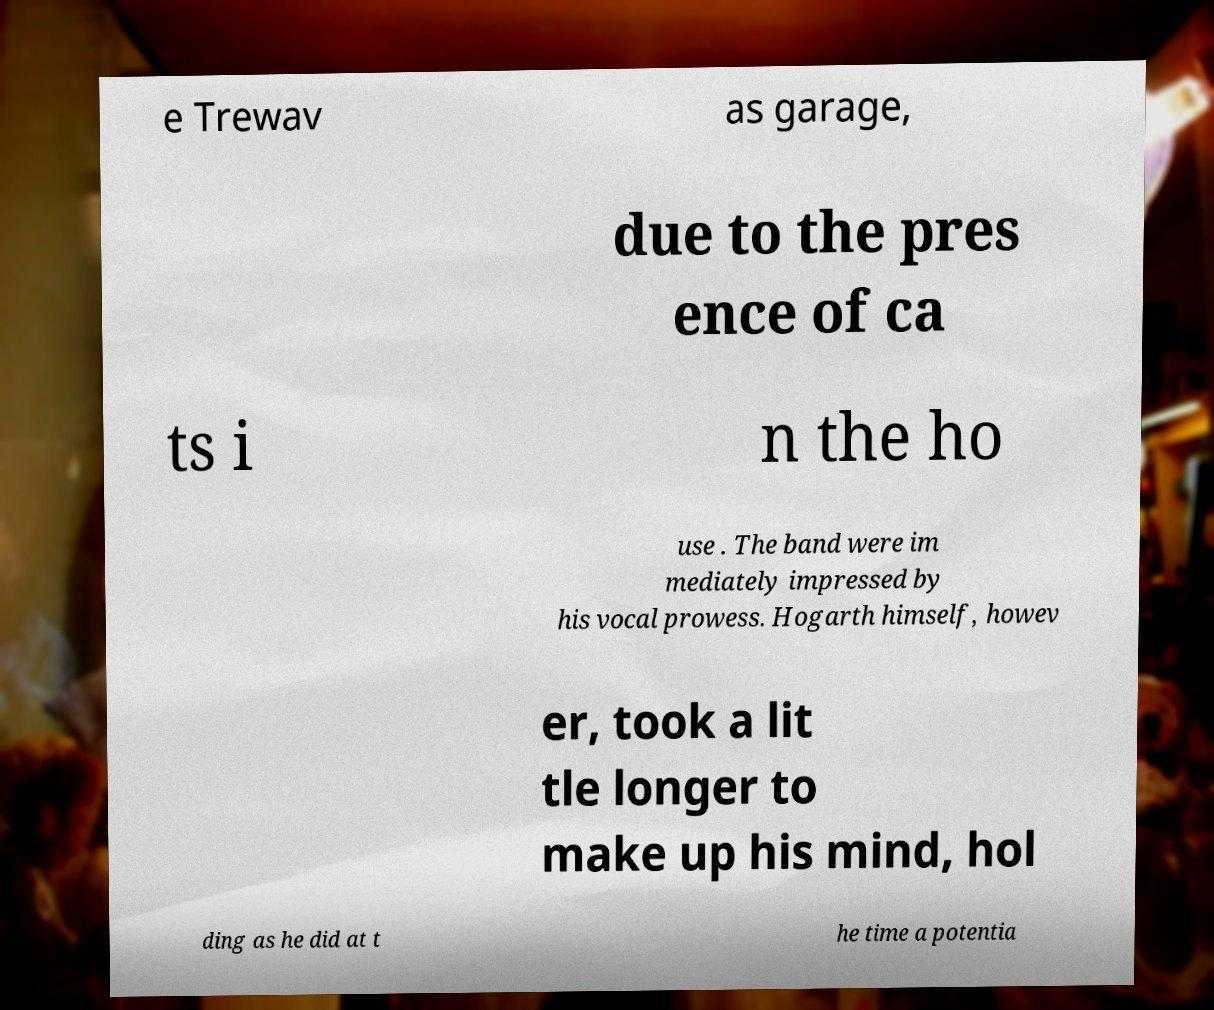Please read and relay the text visible in this image. What does it say? e Trewav as garage, due to the pres ence of ca ts i n the ho use . The band were im mediately impressed by his vocal prowess. Hogarth himself, howev er, took a lit tle longer to make up his mind, hol ding as he did at t he time a potentia 